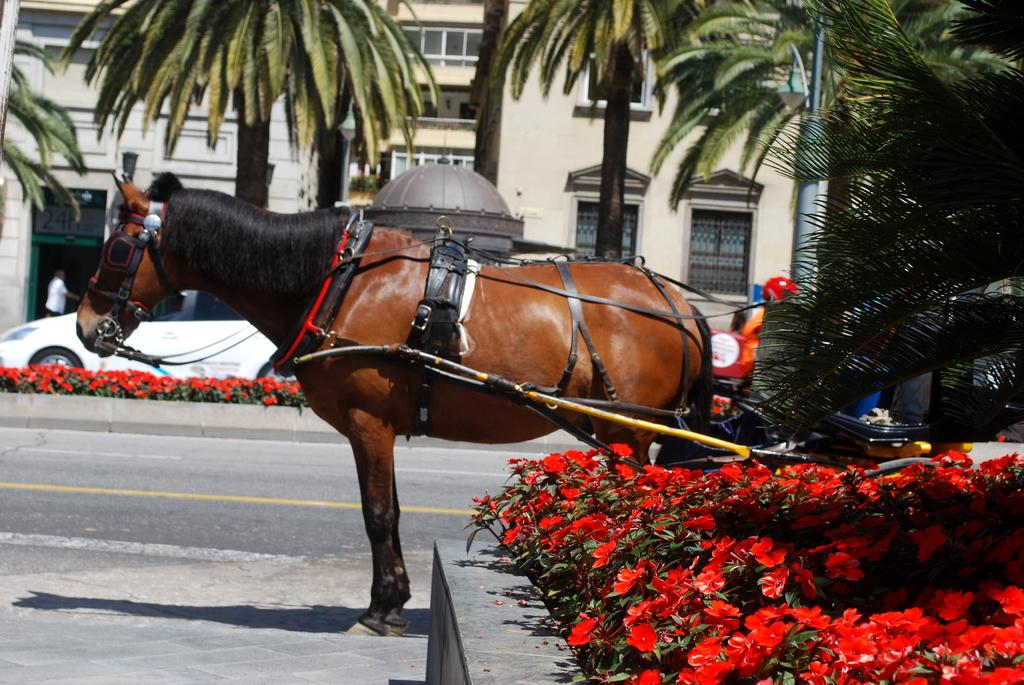What animal is present in the image? There is a horse in the image. What type of vegetation can be seen at the bottom of the image? There are flowers at the bottom of the image. What can be found in the middle of the image? There are trees and a building in the middle of the image. What object is visible in the image? There is a pole visible in the image. What type of prose is being recited by the horse in the image? There is no indication in the image that the horse is reciting any prose, as horses do not have the ability to speak or recite literature. 